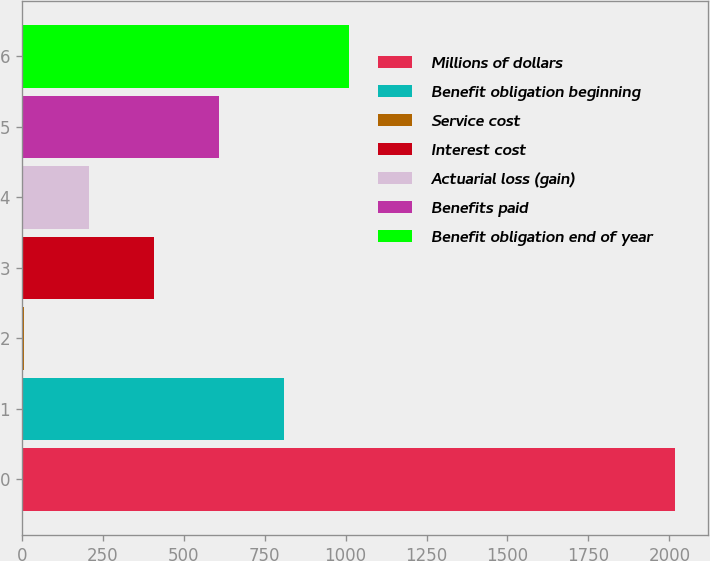Convert chart. <chart><loc_0><loc_0><loc_500><loc_500><bar_chart><fcel>Millions of dollars<fcel>Benefit obligation beginning<fcel>Service cost<fcel>Interest cost<fcel>Actuarial loss (gain)<fcel>Benefits paid<fcel>Benefit obligation end of year<nl><fcel>2017<fcel>811<fcel>7<fcel>409<fcel>208<fcel>610<fcel>1012<nl></chart> 